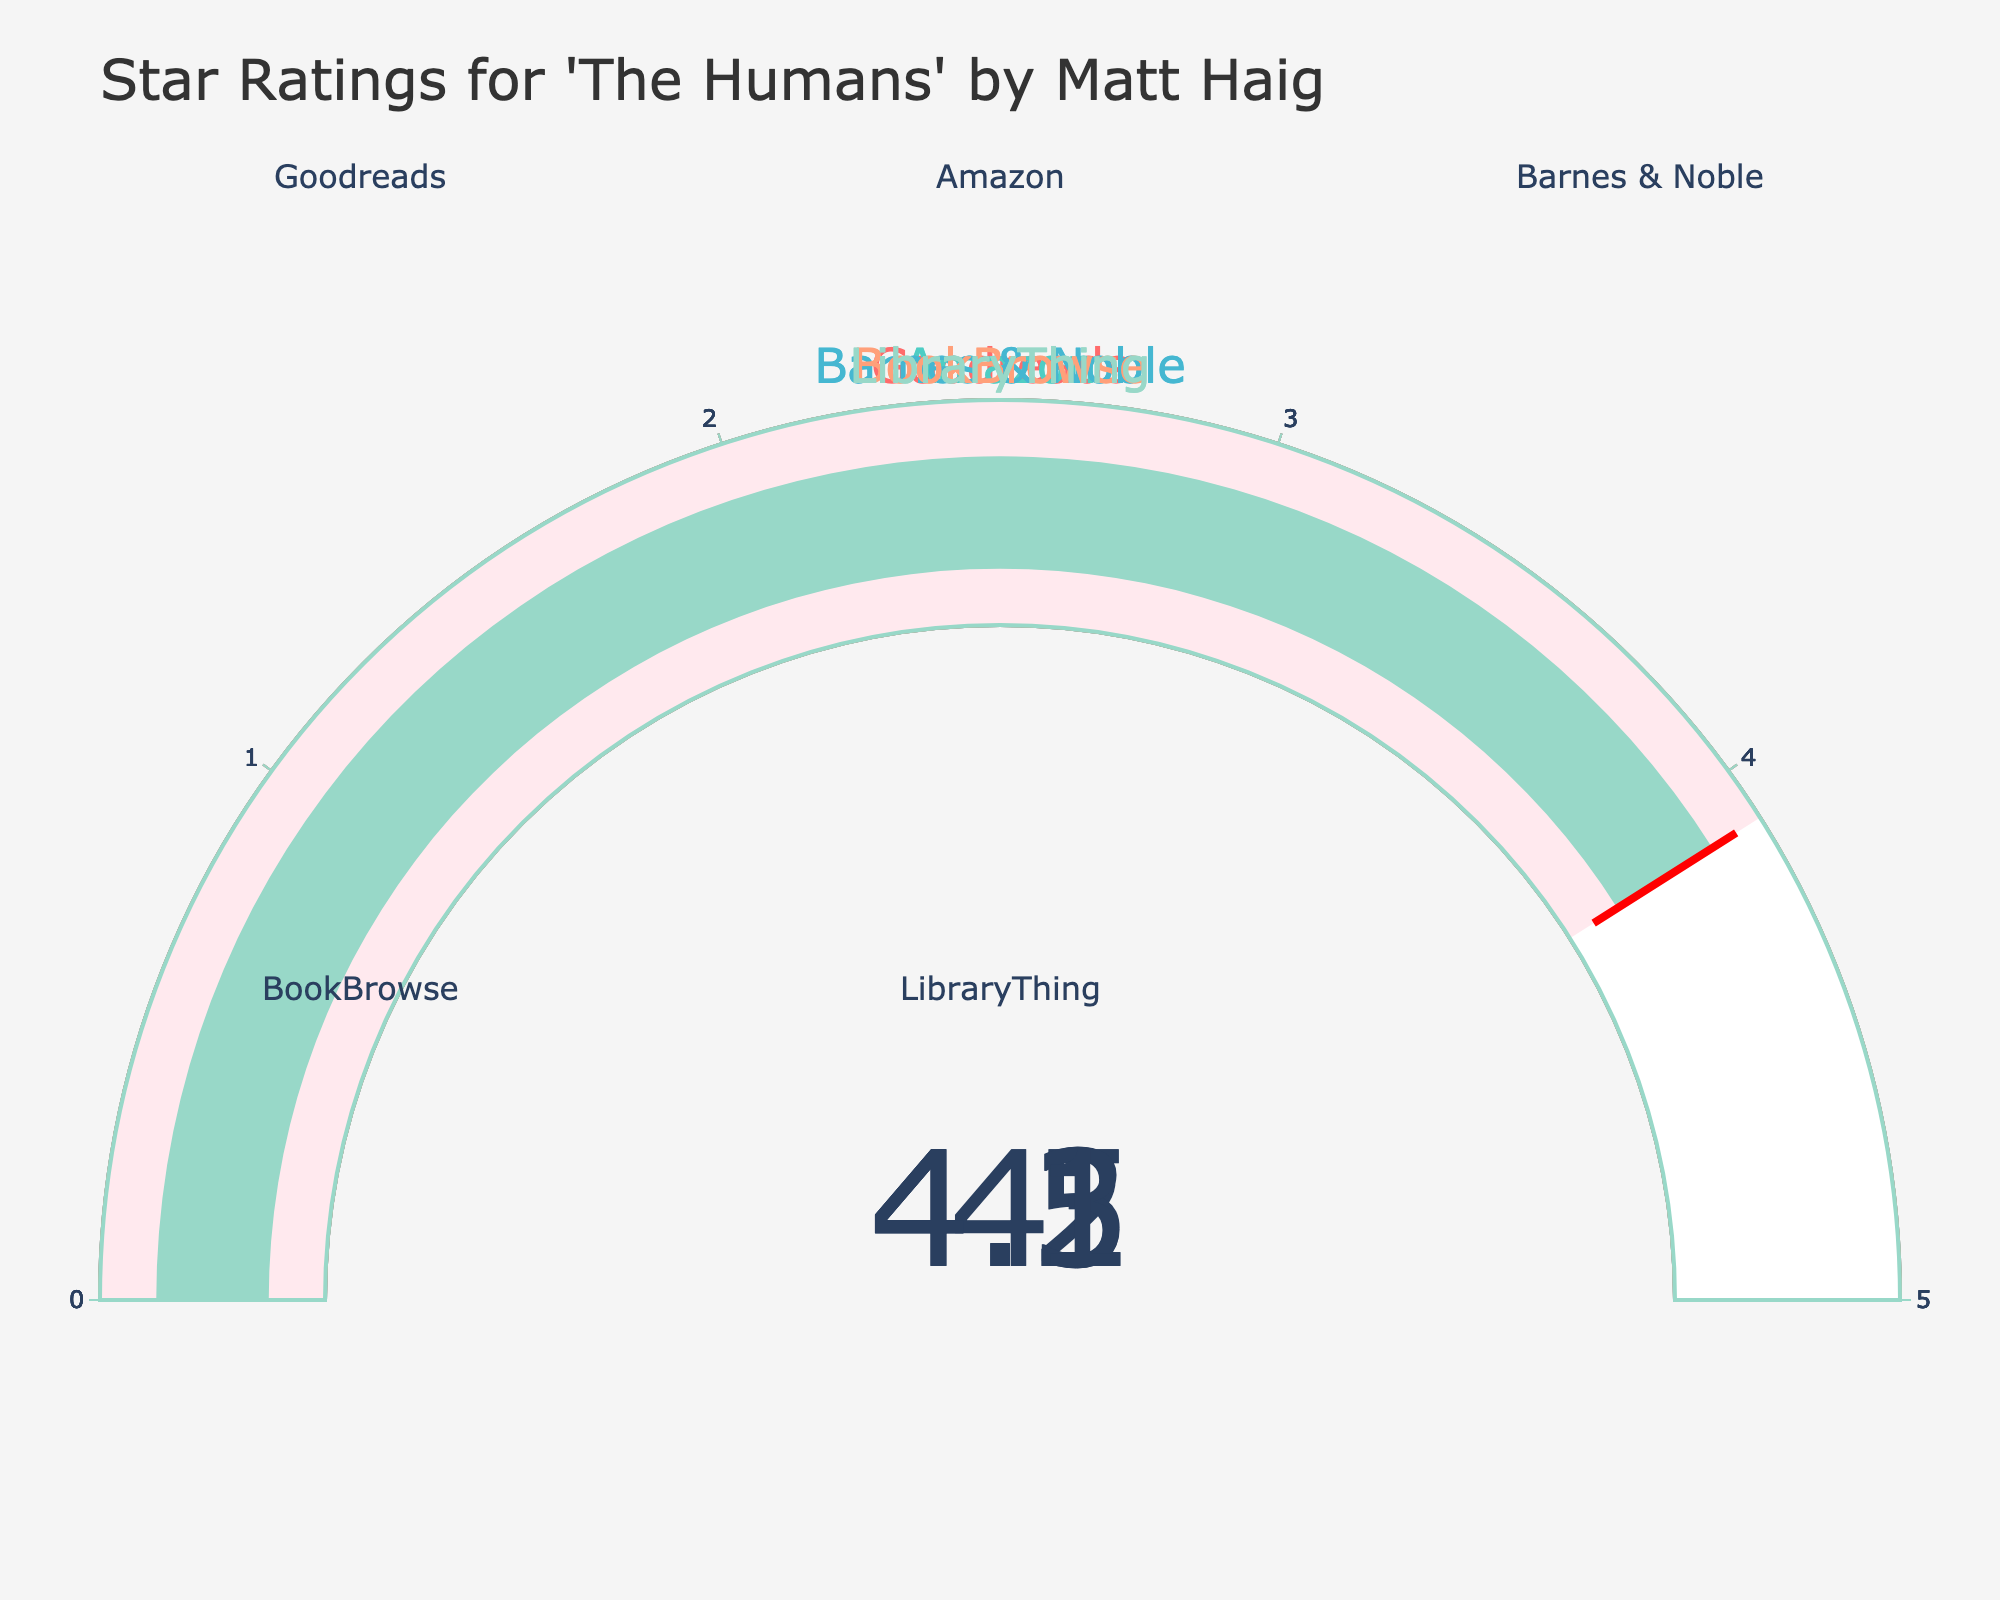What is the star rating for "The Humans" on Goodreads? The star rating for "The Humans" on Goodreads is shown on the gauge chart labeled "Goodreads." You can directly read the value displayed on the gauge.
Answer: 4.2 Which platform has the highest star rating? Compare the values of all the gauge charts and identify the platform with the highest value. Amazon's rating shows 4.5, which is the highest among all platforms.
Answer: Amazon Which platform has the lowest star rating, and what is it? Compare the values of all the gauge charts and identify the platform with the lowest value. BookBrowse has the lowest rating, which is 4.0.
Answer: BookBrowse, 4.0 What is the difference between the star rating on Goodreads and Amazon? Subtract the rating value of Goodreads from the rating value of Amazon. Amazon's rating is 4.5, and Goodreads' rating is 4.2. So, the difference is 4.5 - 4.2 = 0.3.
Answer: 0.3 How many platforms have a star rating above 4.1? Count the number of platforms with a rating higher than 4.1. Both Amazon (4.5) and Barnes & Noble (4.3) have ratings above 4.1, as the other platforms (Goodreads, BookBrowse, LibraryThing) do not exceed 4.1.
Answer: 2 What's the combined average star rating for all the platforms? Add up all the ratings and then divide by the number of platforms. The ratings are 4.2, 4.5, 4.3, 4.0, and 4.1. Summing these values gives 21.1. Dividing by the number of platforms (5) gives 21.1 / 5 = 4.22.
Answer: 4.22 Which platforms have star ratings within the range of 4.1 to 4.3? Identify the platforms with ratings that fall within the specified range. Both Goodreads (4.2) and Barnes & Noble (4.3) fall within the range 4.1 to 4.3.
Answer: Goodreads and Barnes & Noble Is there any platform with a star rating equal to 4.1? Look for platforms with a rating exactly matching 4.1. LibraryThing has a rating equal to 4.1.
Answer: LibraryThing 